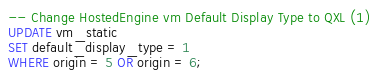Convert code to text. <code><loc_0><loc_0><loc_500><loc_500><_SQL_>-- Change HostedEngine vm Default Display Type to QXL (1)
UPDATE vm_static
SET default_display_type = 1
WHERE origin = 5 OR origin = 6;</code> 